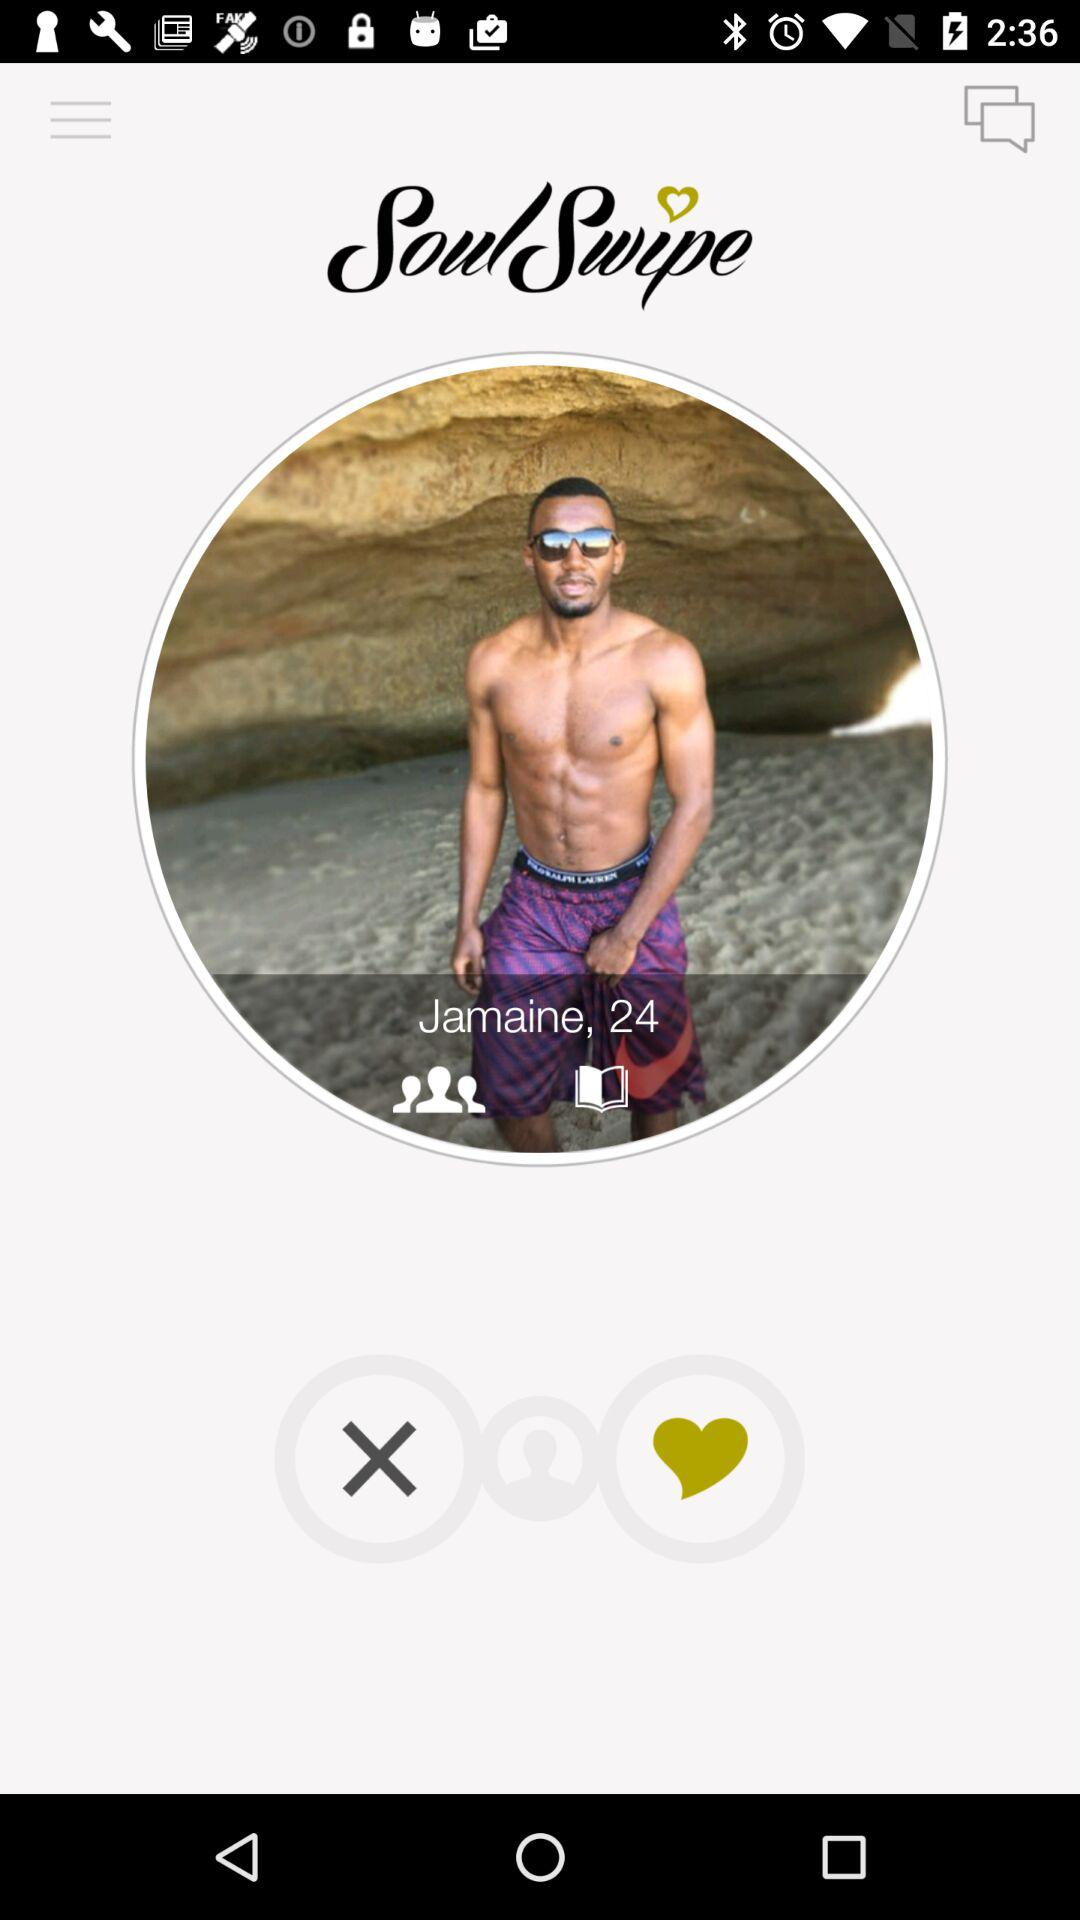What is the name of the user? The name of the user is Jamaine. 